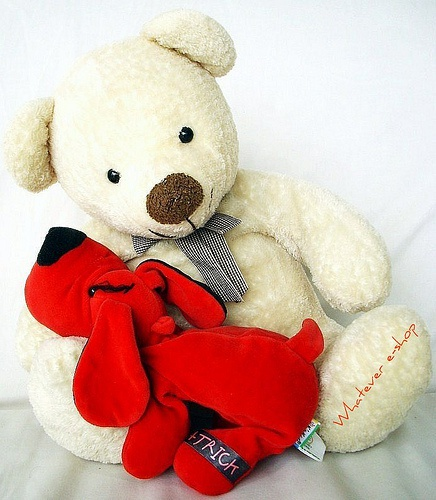Describe the objects in this image and their specific colors. I can see a teddy bear in white, beige, red, and brown tones in this image. 